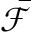Convert formula to latex. <formula><loc_0><loc_0><loc_500><loc_500>\bar { \mathcal { F } }</formula> 